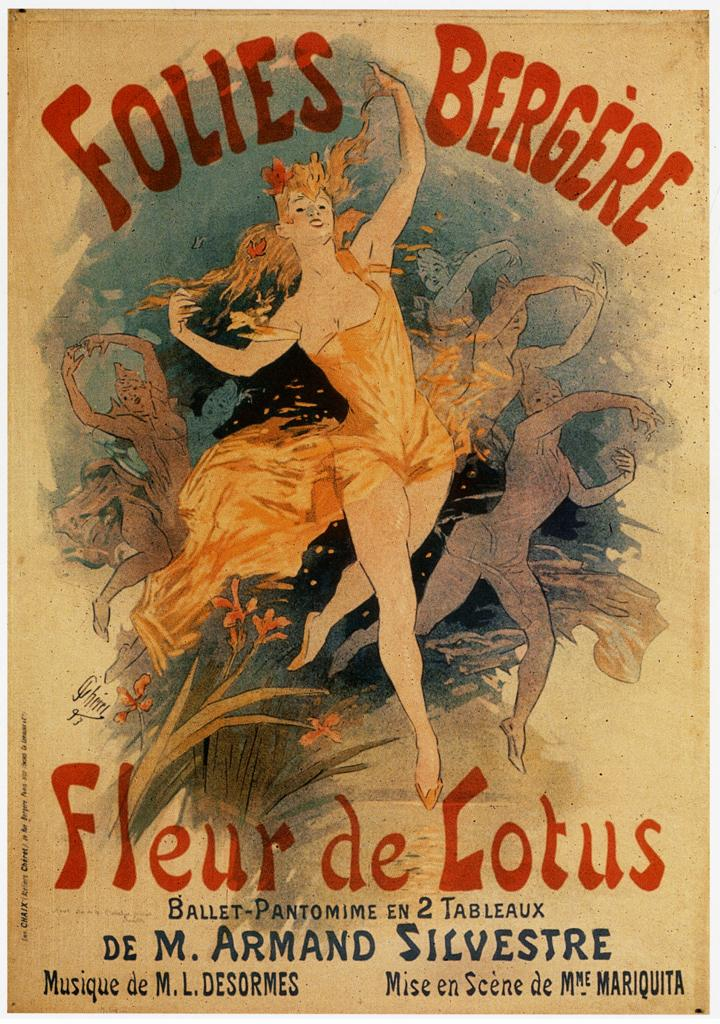What is the main subject in the image? There is a poster in the image. What type of match is being played in the image? There is no match or any indication of a game being played in the image; it only features a poster. 